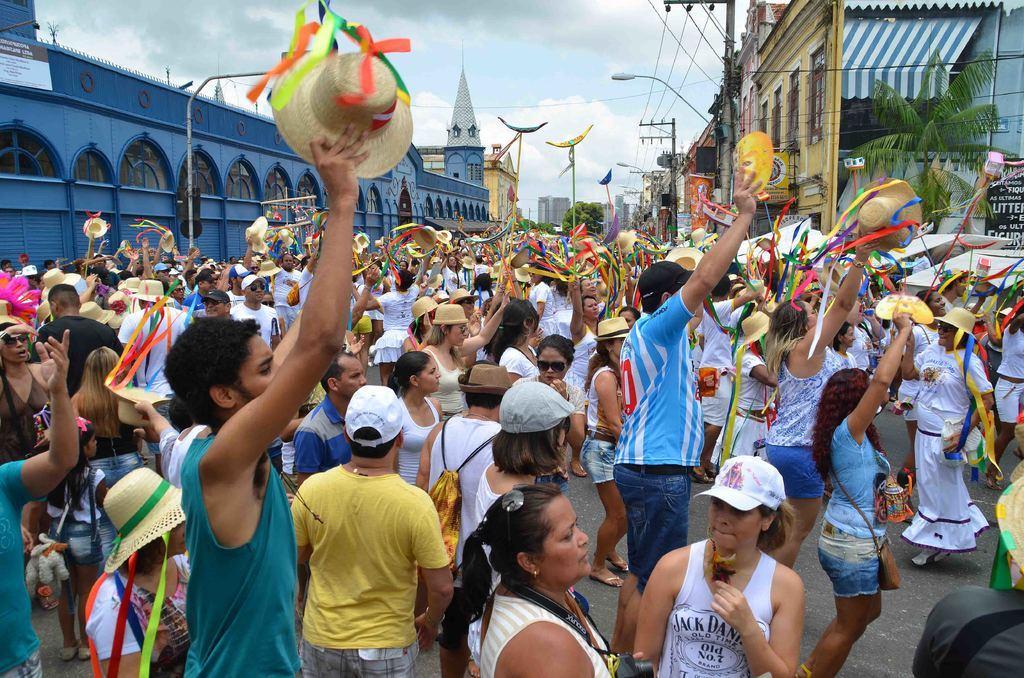In one or two sentences, can you explain what this image depicts? In the center of the image we can see many people standing and holding hats and masks in their hands. In the background there are buildings, poles, lights, wires and sky. On the right there is a tree. 